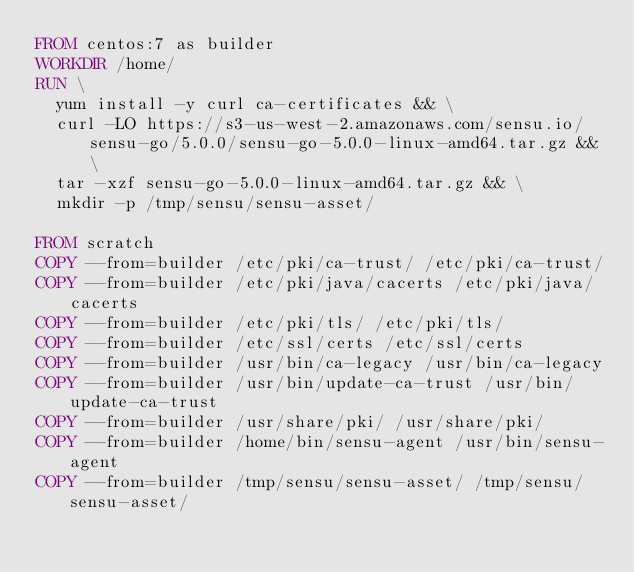Convert code to text. <code><loc_0><loc_0><loc_500><loc_500><_Dockerfile_>FROM centos:7 as builder
WORKDIR /home/
RUN \
  yum install -y curl ca-certificates && \
  curl -LO https://s3-us-west-2.amazonaws.com/sensu.io/sensu-go/5.0.0/sensu-go-5.0.0-linux-amd64.tar.gz && \
  tar -xzf sensu-go-5.0.0-linux-amd64.tar.gz && \
  mkdir -p /tmp/sensu/sensu-asset/

FROM scratch
COPY --from=builder /etc/pki/ca-trust/ /etc/pki/ca-trust/
COPY --from=builder /etc/pki/java/cacerts /etc/pki/java/cacerts
COPY --from=builder /etc/pki/tls/ /etc/pki/tls/
COPY --from=builder /etc/ssl/certs /etc/ssl/certs
COPY --from=builder /usr/bin/ca-legacy /usr/bin/ca-legacy
COPY --from=builder /usr/bin/update-ca-trust /usr/bin/update-ca-trust
COPY --from=builder /usr/share/pki/ /usr/share/pki/
COPY --from=builder /home/bin/sensu-agent /usr/bin/sensu-agent
COPY --from=builder /tmp/sensu/sensu-asset/ /tmp/sensu/sensu-asset/
</code> 